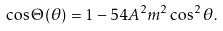<formula> <loc_0><loc_0><loc_500><loc_500>\cos \Theta ( \theta ) = 1 - 5 4 A ^ { 2 } m ^ { 2 } \cos ^ { 2 } \theta .</formula> 